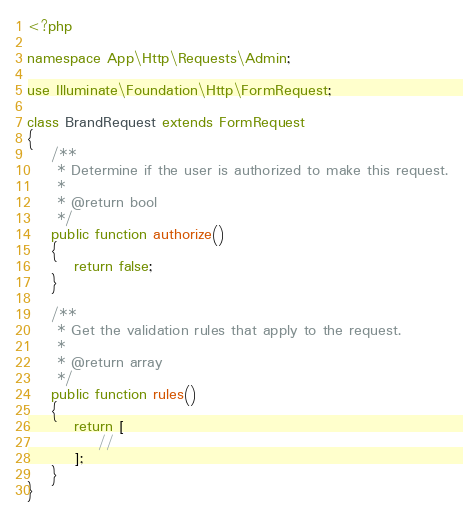<code> <loc_0><loc_0><loc_500><loc_500><_PHP_><?php

namespace App\Http\Requests\Admin;

use Illuminate\Foundation\Http\FormRequest;

class BrandRequest extends FormRequest
{
    /**
     * Determine if the user is authorized to make this request.
     *
     * @return bool
     */
    public function authorize()
    {
        return false;
    }

    /**
     * Get the validation rules that apply to the request.
     *
     * @return array
     */
    public function rules()
    {
        return [
            //
        ];
    }
}
</code> 